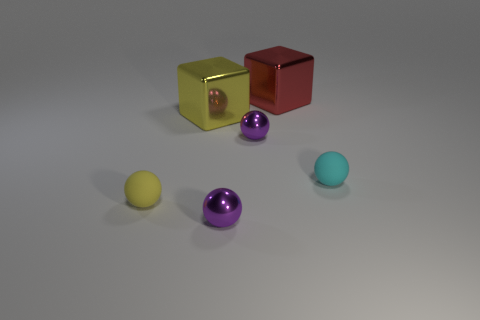Add 2 cyan objects. How many objects exist? 8 Subtract all blocks. How many objects are left? 4 Subtract 0 green spheres. How many objects are left? 6 Subtract all small red rubber cylinders. Subtract all purple metal balls. How many objects are left? 4 Add 2 large yellow cubes. How many large yellow cubes are left? 3 Add 4 tiny brown shiny cylinders. How many tiny brown shiny cylinders exist? 4 